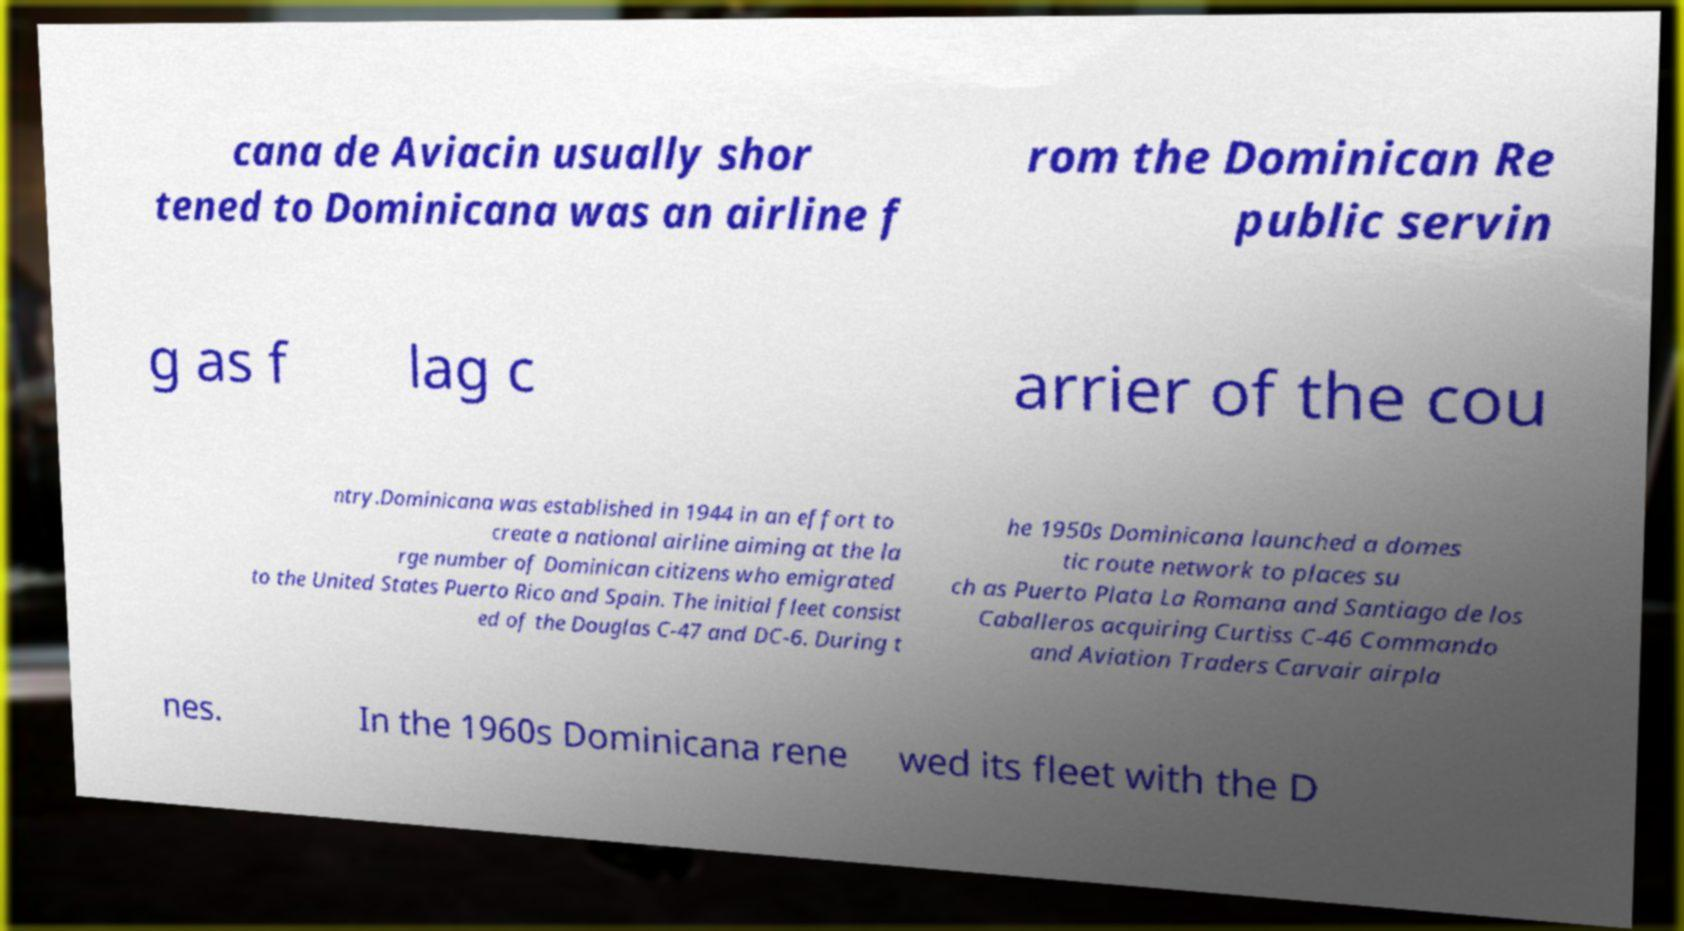Could you assist in decoding the text presented in this image and type it out clearly? cana de Aviacin usually shor tened to Dominicana was an airline f rom the Dominican Re public servin g as f lag c arrier of the cou ntry.Dominicana was established in 1944 in an effort to create a national airline aiming at the la rge number of Dominican citizens who emigrated to the United States Puerto Rico and Spain. The initial fleet consist ed of the Douglas C-47 and DC-6. During t he 1950s Dominicana launched a domes tic route network to places su ch as Puerto Plata La Romana and Santiago de los Caballeros acquiring Curtiss C-46 Commando and Aviation Traders Carvair airpla nes. In the 1960s Dominicana rene wed its fleet with the D 